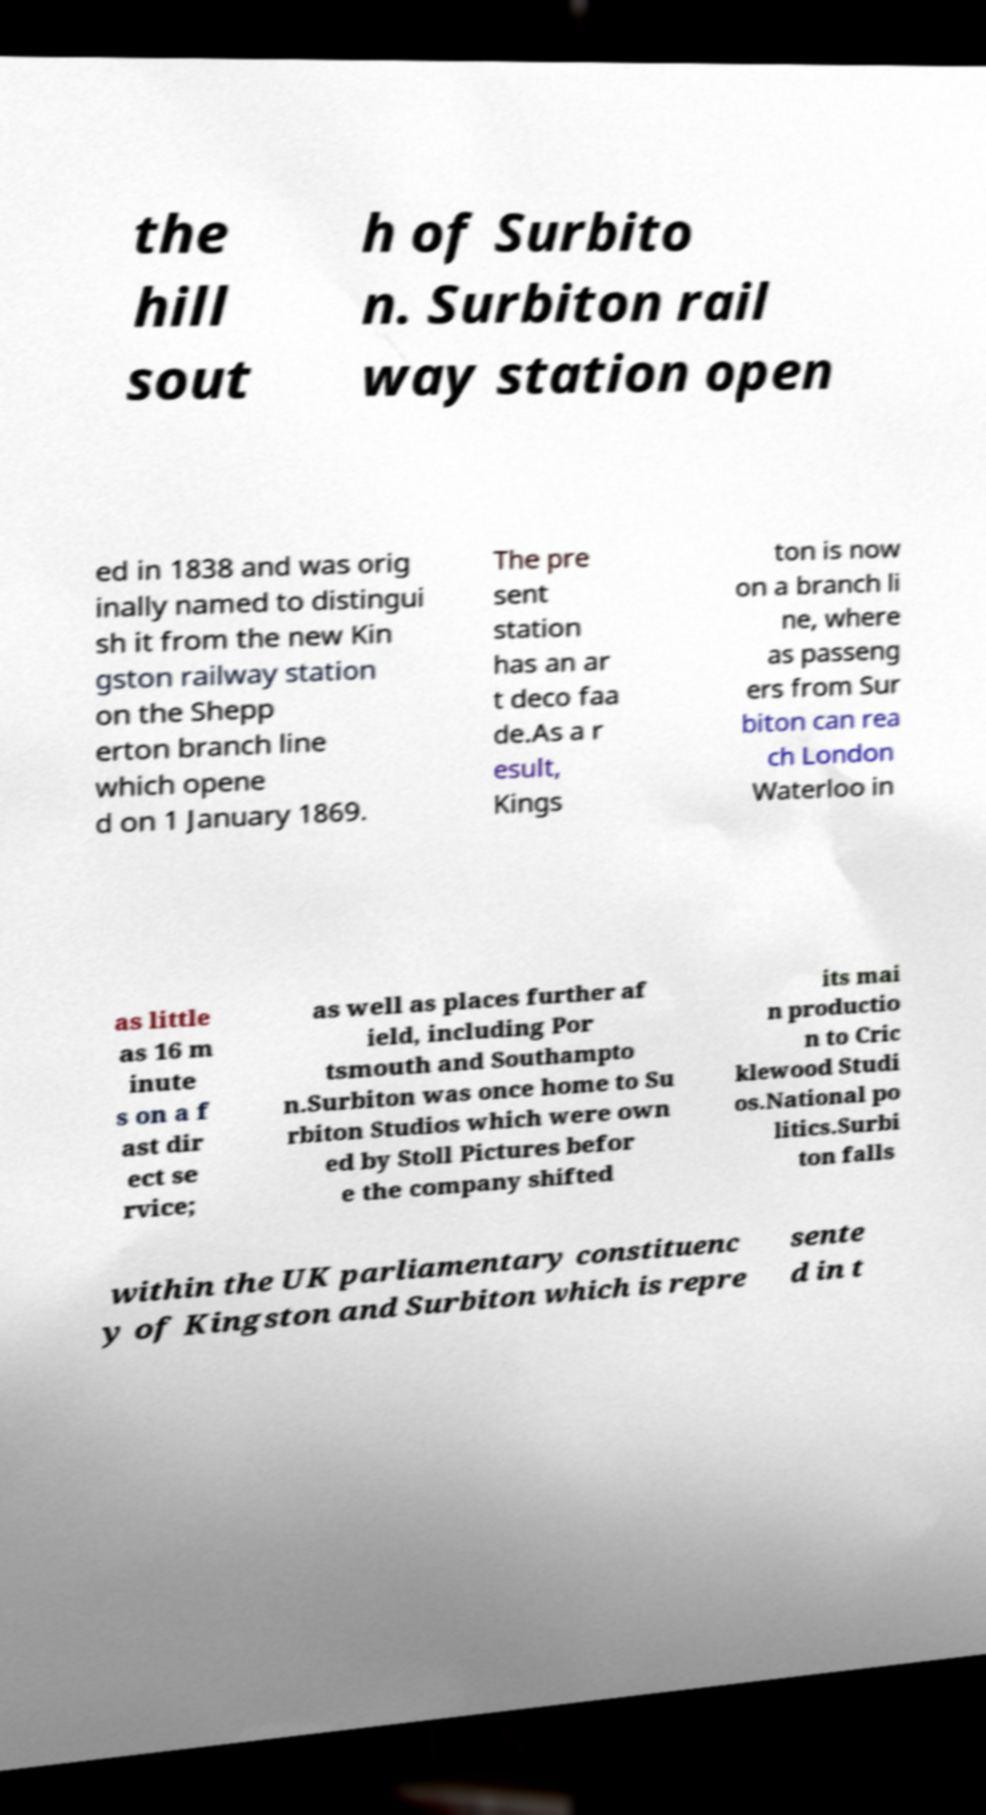Please identify and transcribe the text found in this image. the hill sout h of Surbito n. Surbiton rail way station open ed in 1838 and was orig inally named to distingui sh it from the new Kin gston railway station on the Shepp erton branch line which opene d on 1 January 1869. The pre sent station has an ar t deco faa de.As a r esult, Kings ton is now on a branch li ne, where as passeng ers from Sur biton can rea ch London Waterloo in as little as 16 m inute s on a f ast dir ect se rvice; as well as places further af ield, including Por tsmouth and Southampto n.Surbiton was once home to Su rbiton Studios which were own ed by Stoll Pictures befor e the company shifted its mai n productio n to Cric klewood Studi os.National po litics.Surbi ton falls within the UK parliamentary constituenc y of Kingston and Surbiton which is repre sente d in t 